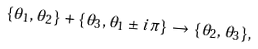Convert formula to latex. <formula><loc_0><loc_0><loc_500><loc_500>\{ \theta _ { 1 } , \theta _ { 2 } \} + \{ \theta _ { 3 } , \theta _ { 1 } \pm i \pi \} \rightarrow \{ \theta _ { 2 } , \theta _ { 3 } \} ,</formula> 